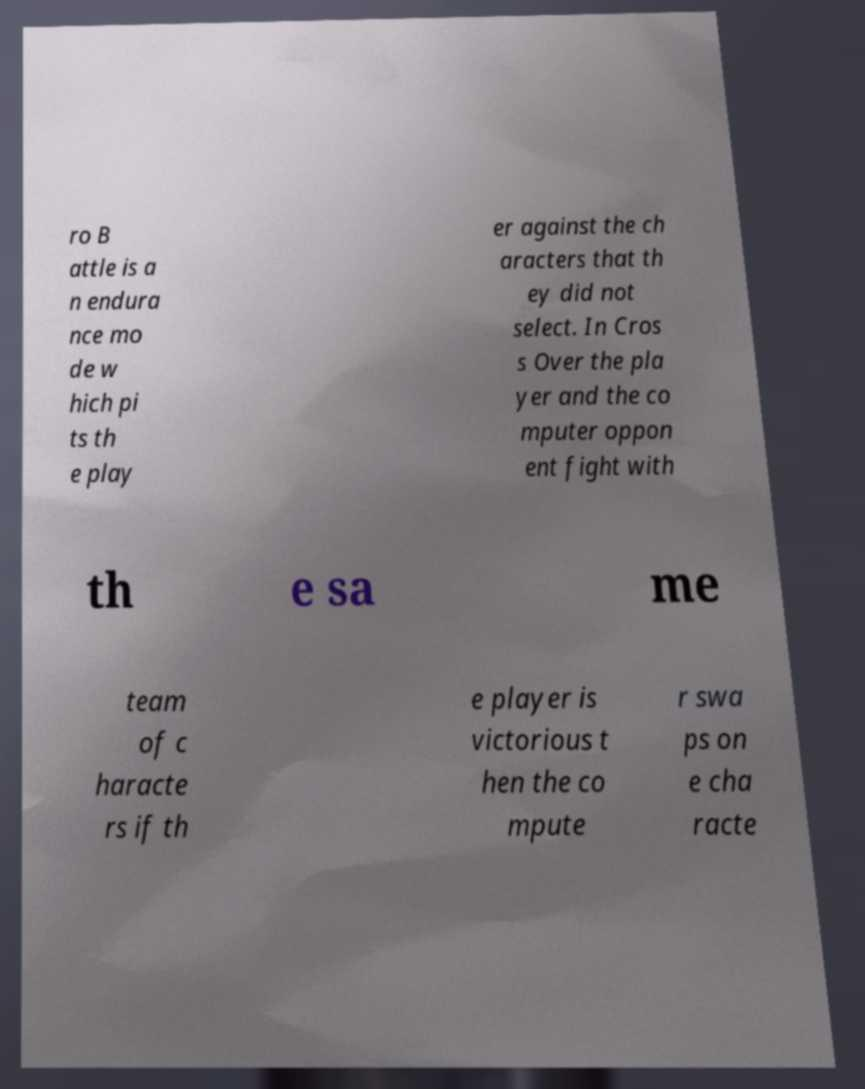What messages or text are displayed in this image? I need them in a readable, typed format. ro B attle is a n endura nce mo de w hich pi ts th e play er against the ch aracters that th ey did not select. In Cros s Over the pla yer and the co mputer oppon ent fight with th e sa me team of c haracte rs if th e player is victorious t hen the co mpute r swa ps on e cha racte 